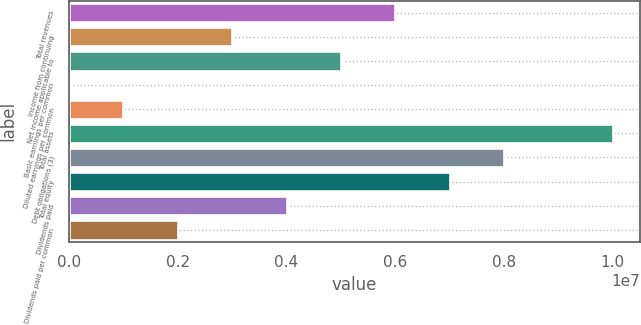Convert chart. <chart><loc_0><loc_0><loc_500><loc_500><bar_chart><fcel>Total revenues<fcel>Income from continuing<fcel>Net income applicable to<fcel>Basic earnings per common<fcel>Diluted earnings per common<fcel>Total assets<fcel>Debt obligations (3)<fcel>Total equity<fcel>Dividends paid<fcel>Dividends paid per common<nl><fcel>6.00765e+06<fcel>3.00382e+06<fcel>5.00637e+06<fcel>0.06<fcel>1.00127e+06<fcel>1.00127e+07<fcel>8.0102e+06<fcel>7.00892e+06<fcel>4.0051e+06<fcel>2.00255e+06<nl></chart> 